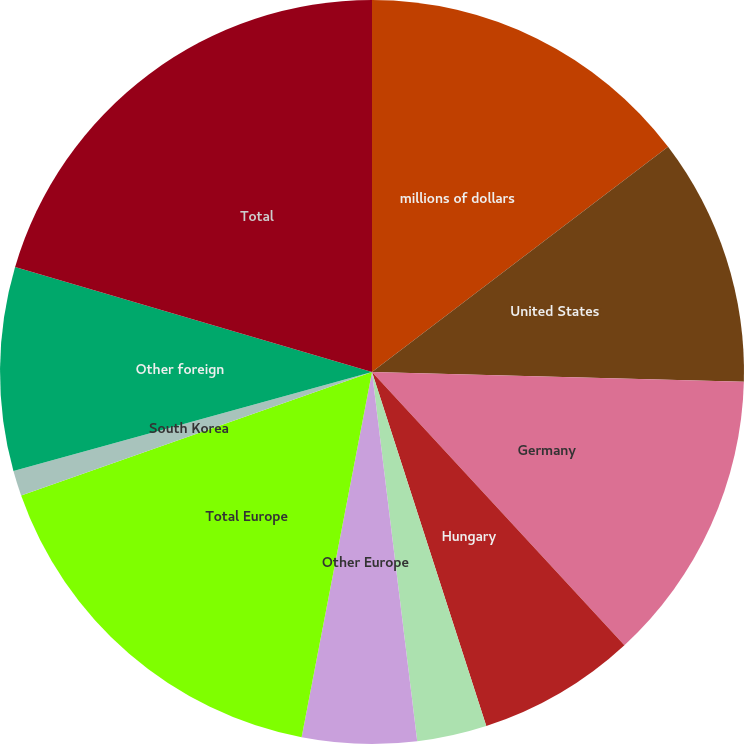<chart> <loc_0><loc_0><loc_500><loc_500><pie_chart><fcel>millions of dollars<fcel>United States<fcel>Germany<fcel>Hungary<fcel>France<fcel>Other Europe<fcel>Total Europe<fcel>South Korea<fcel>Other foreign<fcel>Total<nl><fcel>14.65%<fcel>10.77%<fcel>12.71%<fcel>6.9%<fcel>3.03%<fcel>4.97%<fcel>16.58%<fcel>1.1%<fcel>8.84%<fcel>20.45%<nl></chart> 